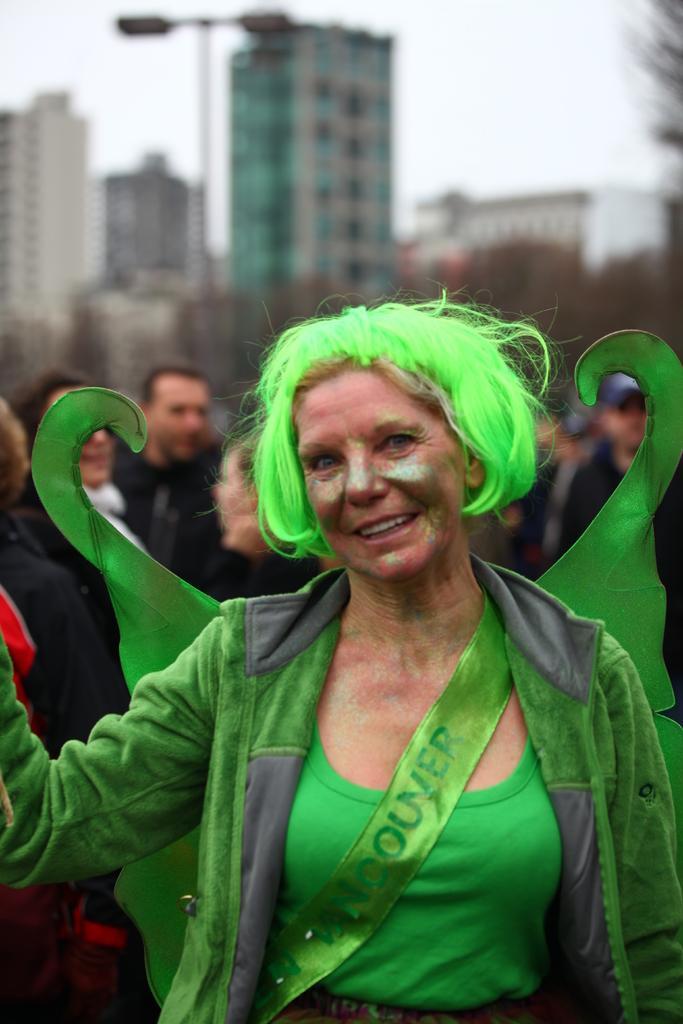How would you summarize this image in a sentence or two? In the picture I can see a woman wearing green color dress, green color hair, different costume and face painting on her face is standing here and smiling. The background of the image is slightly blurred, where we can see a few more people standing, we can see like poles, buildings and the sky. 